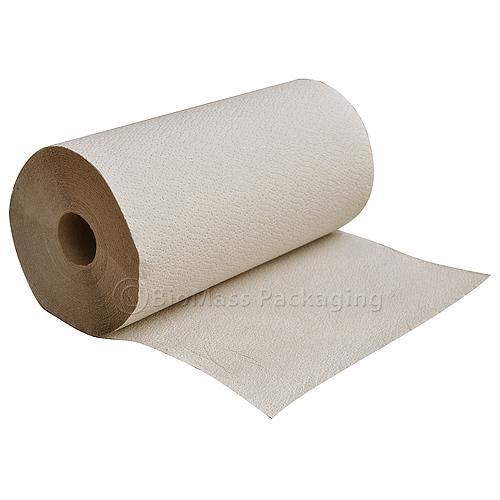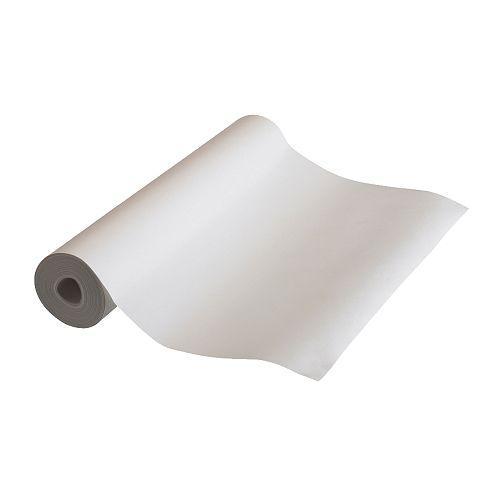The first image is the image on the left, the second image is the image on the right. Considering the images on both sides, is "An image features one upright towel row the color of brown kraft paper." valid? Answer yes or no. No. 